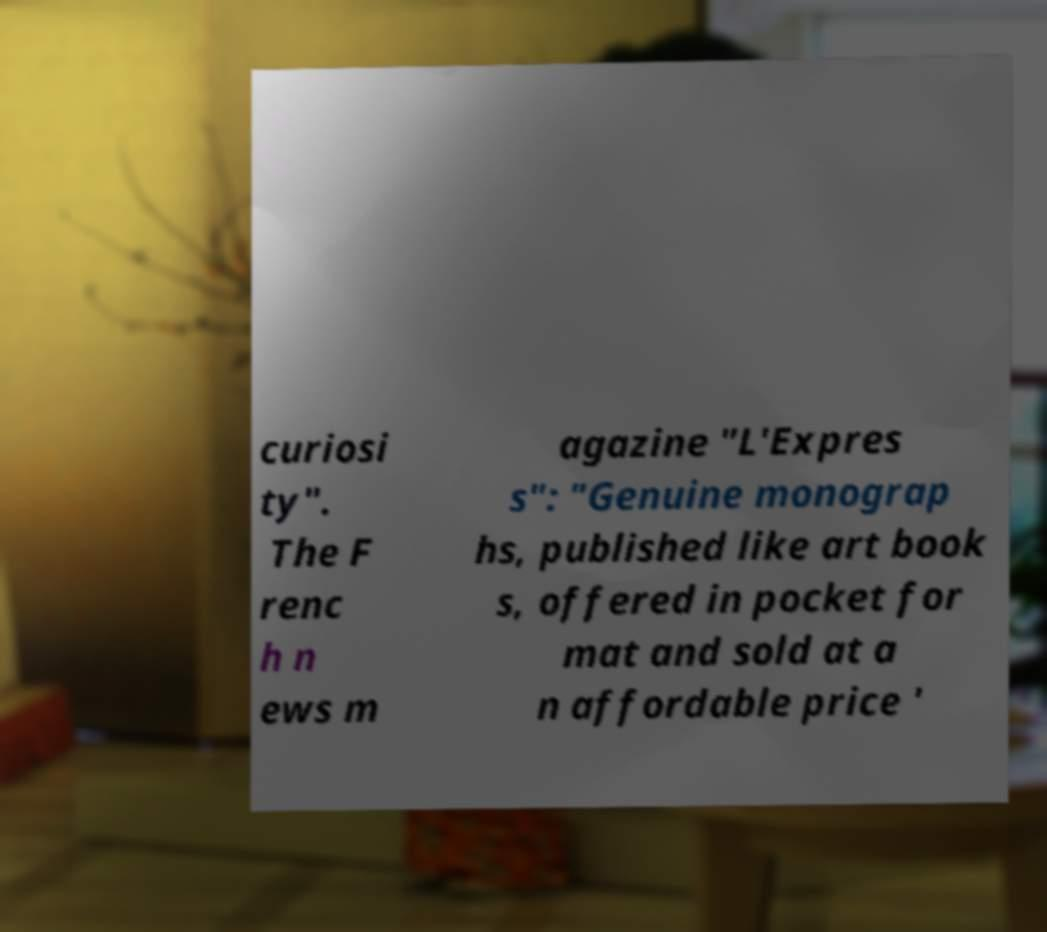What messages or text are displayed in this image? I need them in a readable, typed format. curiosi ty". The F renc h n ews m agazine "L'Expres s": "Genuine monograp hs, published like art book s, offered in pocket for mat and sold at a n affordable price ' 